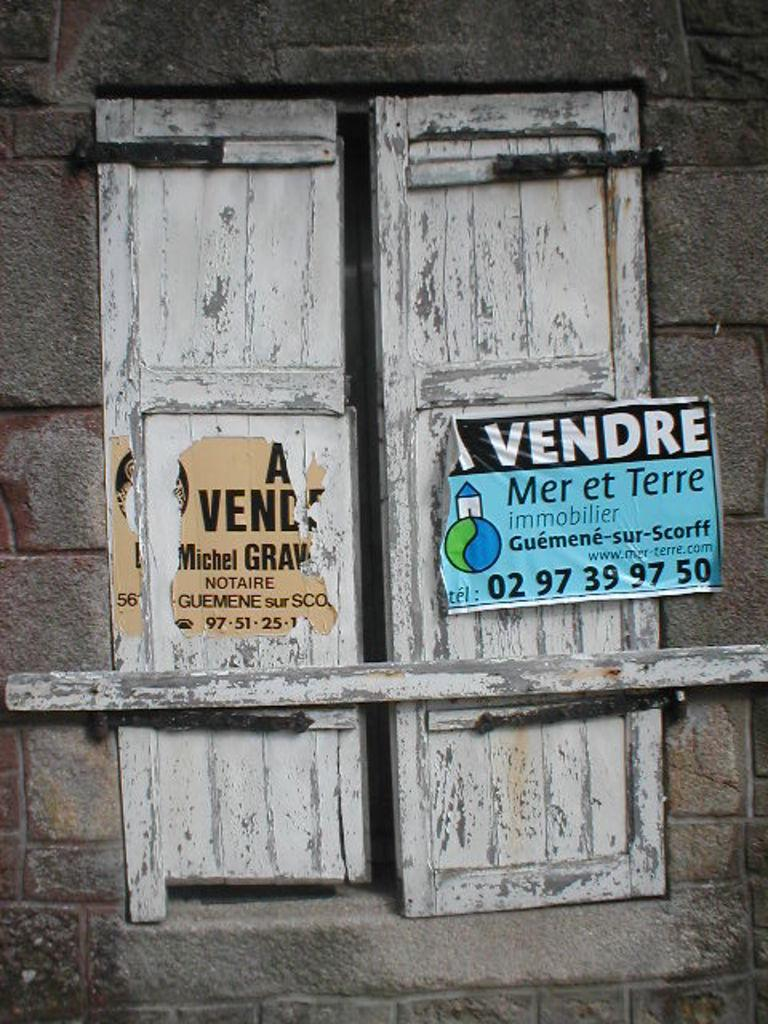What type of structure can be seen in the image? There is a wall in the image. Is there any opening in the wall? Yes, there is a window in the wall. What else can be seen on the wall? There is a poster in the image. What type of river is depicted in the poster? There is no river present in the image, as the poster is not described in detail. 